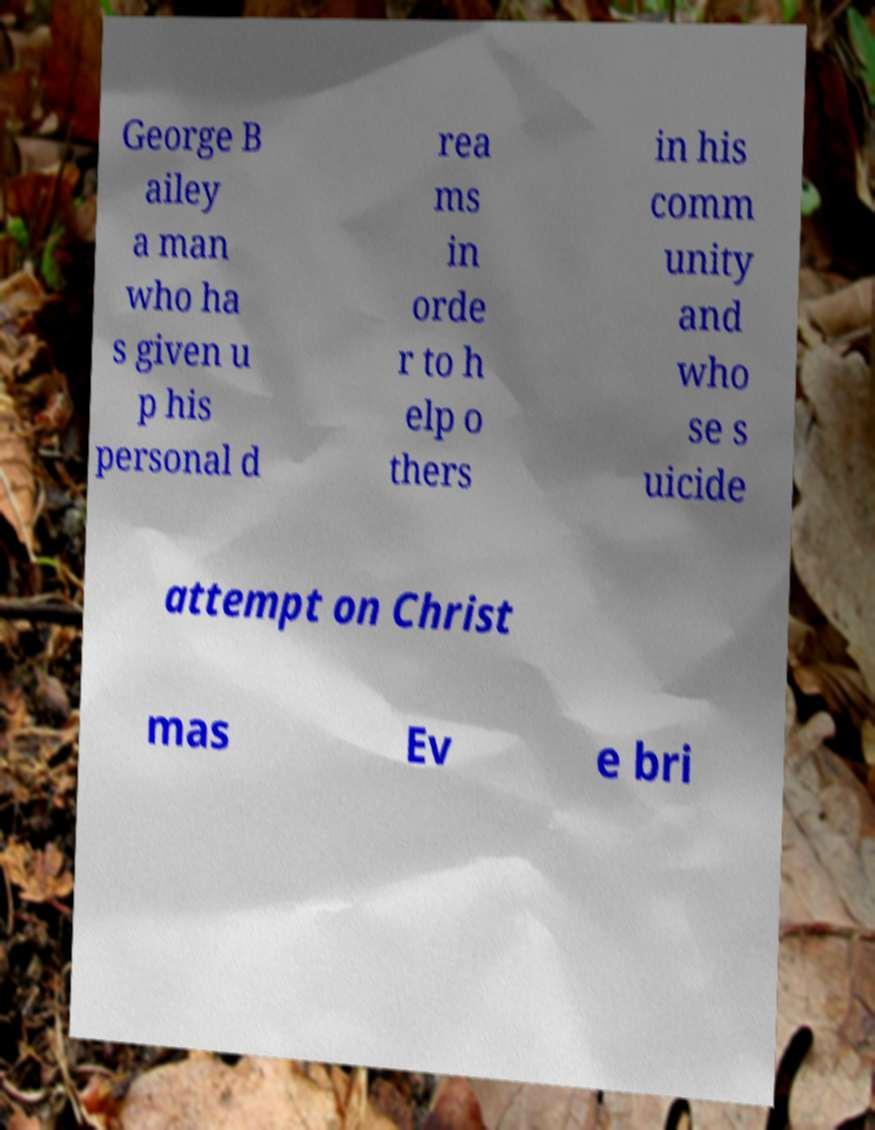Could you assist in decoding the text presented in this image and type it out clearly? George B ailey a man who ha s given u p his personal d rea ms in orde r to h elp o thers in his comm unity and who se s uicide attempt on Christ mas Ev e bri 